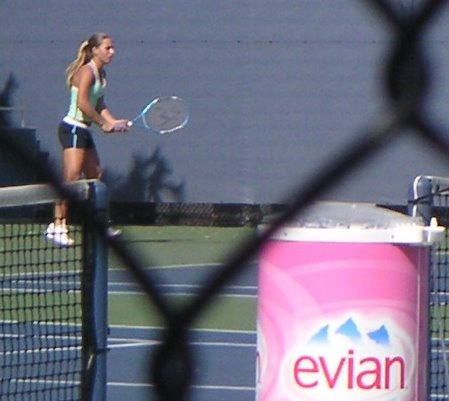Describe the objects in this image and their specific colors. I can see people in gray, tan, and maroon tones and tennis racket in gray and darkgray tones in this image. 